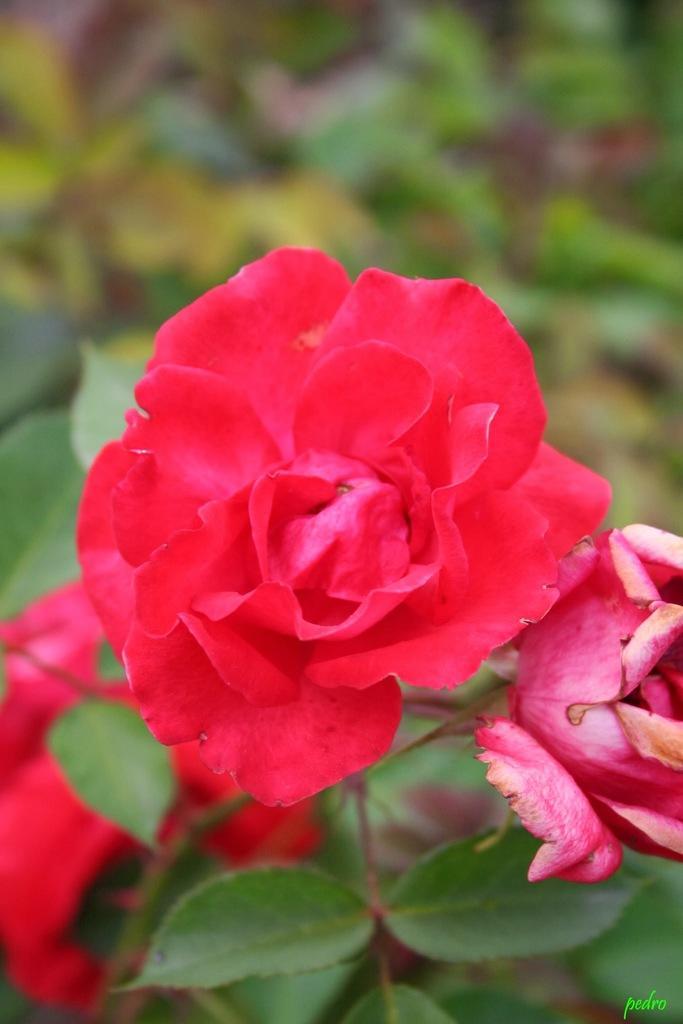Could you give a brief overview of what you see in this image? In this image there are three beautiful red roses with leaves the background is blurry. 